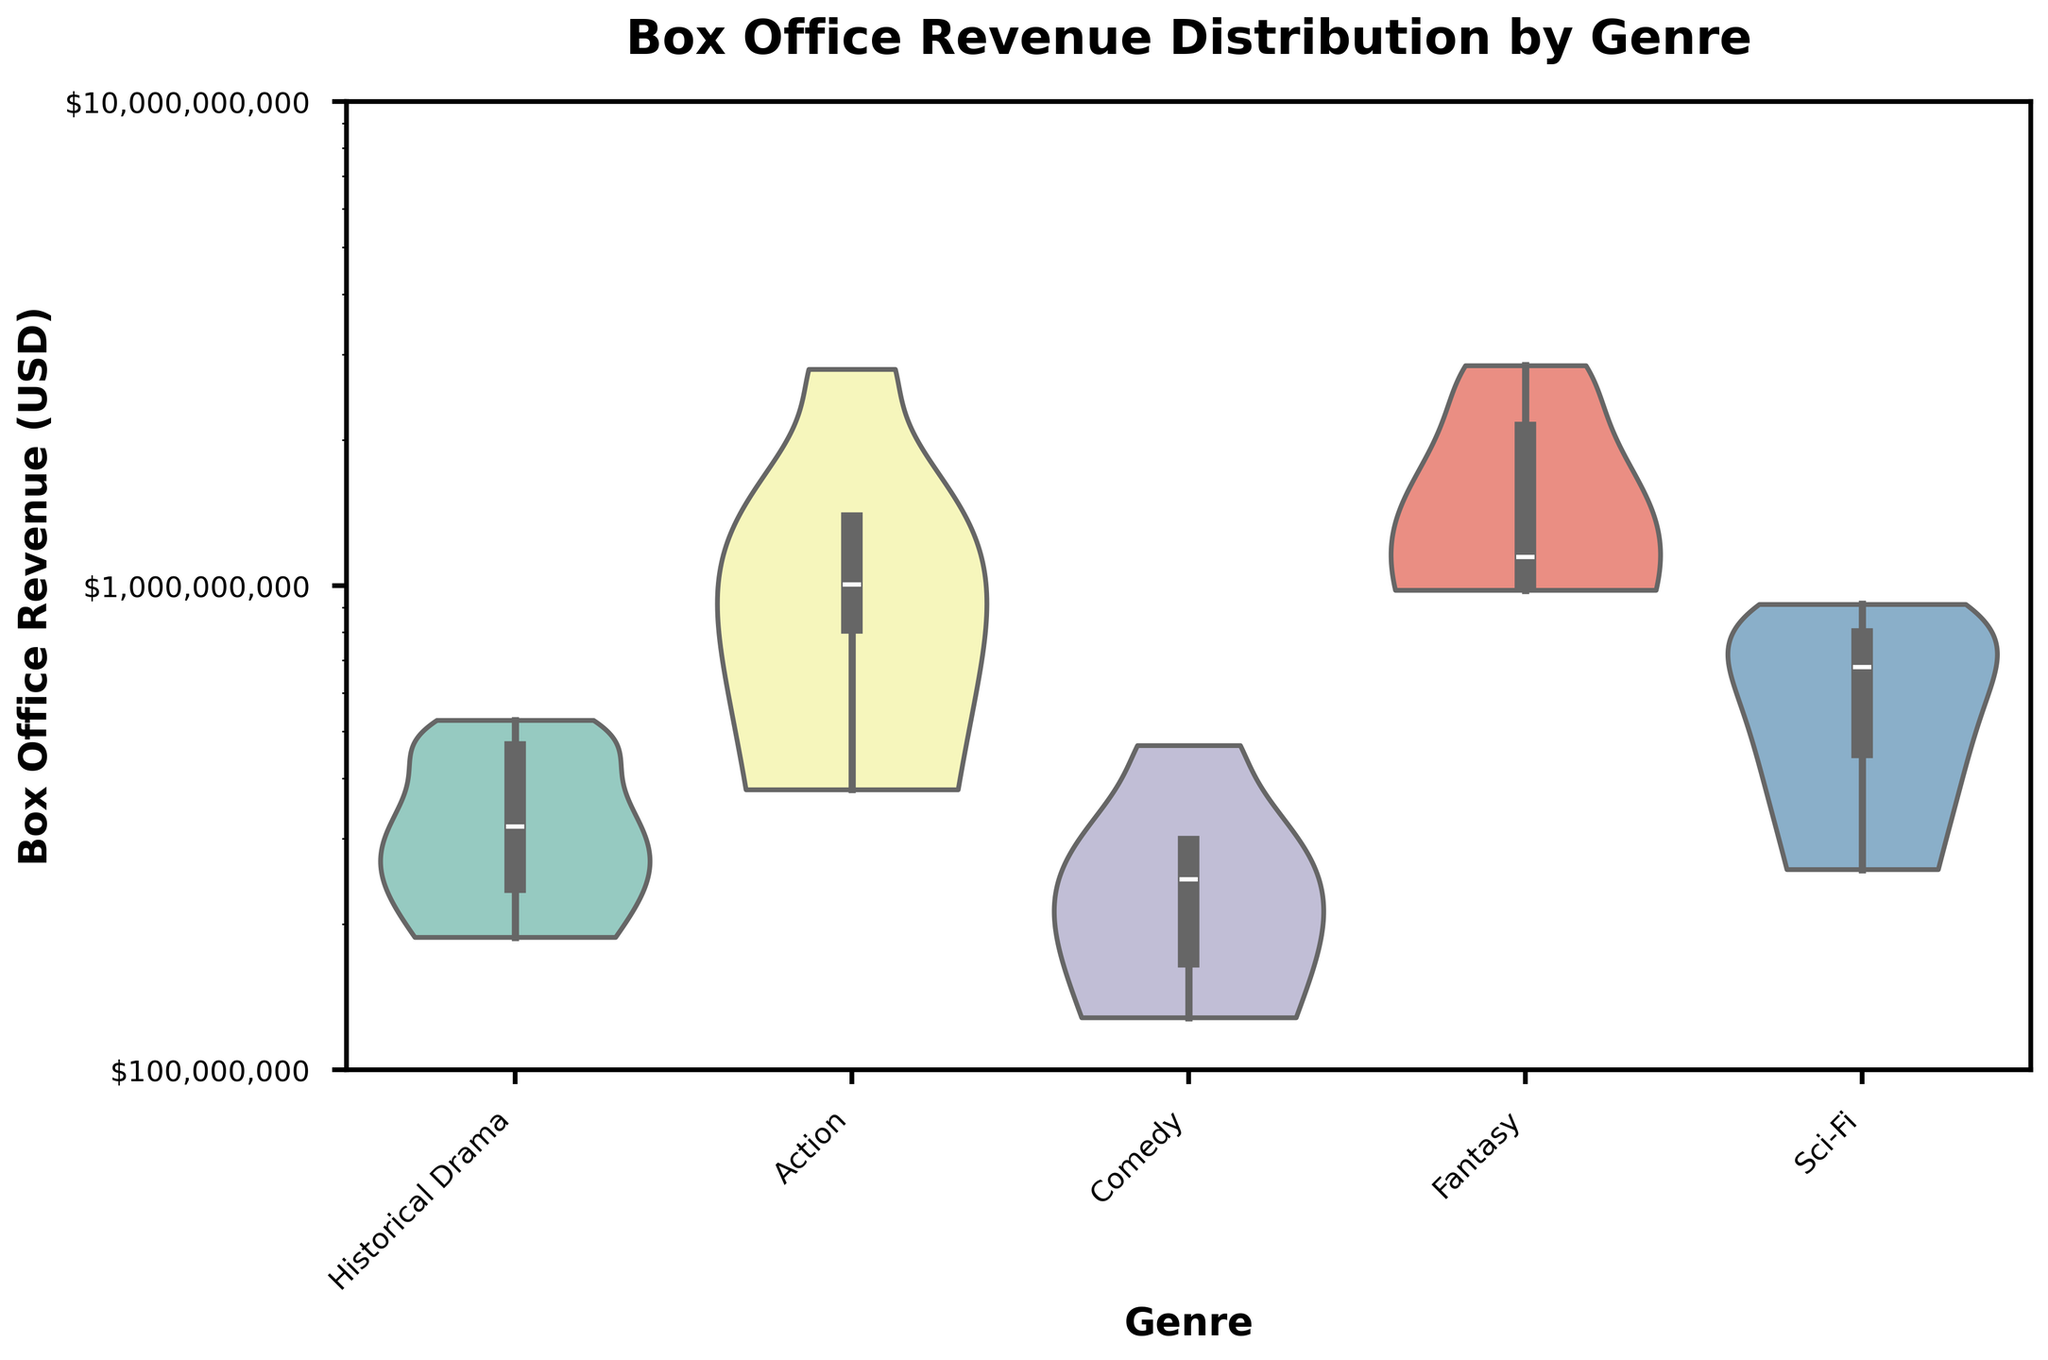What is the title of the figure? The title is usually located above the figure and it summarizes what the figure is about. Here, it reads "Box Office Revenue Distribution by Genre".
Answer: Box Office Revenue Distribution by Genre What does the y-axis represent? The y-axis denotes the values plotted in the figure. Here, it is labeled "Box Office Revenue (USD)", which means it represents the box office revenue of the films.
Answer: Box Office Revenue (USD) What is the scale used on the y-axis? The scale on the y-axis can often be determined by the appearance and labels of the axis. In this case, it uses a logarithmic scale which is evident from the increasing magnitude of the values (1e8, 1e9) and mentioned in the code.
Answer: Logarithmic scale Which genre has the highest median box office revenue? In violin plots, the median is typically indicated by the horizontal line within the distribution. Here, the genre with the highest median line appears to be Fantasy.
Answer: Fantasy How does the distribution width of "Historical Drama" compare to "Action"? To compare widths, look at how spread out the data points are. "Historical Drama" has a relatively narrower width compared to "Action" which shows a wider range, indicating more variability in its box office revenue.
Answer: Action is wider than Historical Drama Do any genres show a clear multimodal distribution, and which genre if so? A multimodal distribution has multiple peaks or modes. From the plots, none of the genres show clear, distinct multiple modes; they mostly appear unimodal.
Answer: None Between "Comedy" and "Sci-Fi", which genre shows a higher range of box office revenues? The range can be determined by the overall height of the violin plot. "Sci-Fi" shows a larger height compared to "Comedy", indicating a higher range in box office revenues.
Answer: Sci-Fi Which genre shows the least variability in box office revenue? Variability is indicated by the width at the widest part of the violin plot. "Historical Drama" has a more concentrated and narrow distribution, suggesting it has the least variability.
Answer: Historical Drama Are there any outliers in the "Sci-Fi" genre? Outliers in violin plots can show as points or small extensions beyond the main distribution. In "Sci-Fi", there don't appear to be significant outliers beyond the main body of data.
Answer: No Is the revenue distribution skewed for "Fantasy" films and in which direction? Skewness in a violin plot can be seen by the shape. "Fantasy" shows a long tail extending towards higher revenues, indicating a positive skew.
Answer: Positive skew 